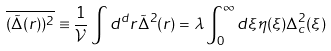Convert formula to latex. <formula><loc_0><loc_0><loc_500><loc_500>\overline { ( \tilde { \Delta } ( r ) ) ^ { 2 } } \equiv \frac { 1 } { \mathcal { V } } \int d ^ { d } r \tilde { \Delta } ^ { 2 } ( r ) = \lambda \int _ { 0 } ^ { \infty } d \xi \eta ( \xi ) \Delta _ { c } ^ { 2 } ( \xi )</formula> 